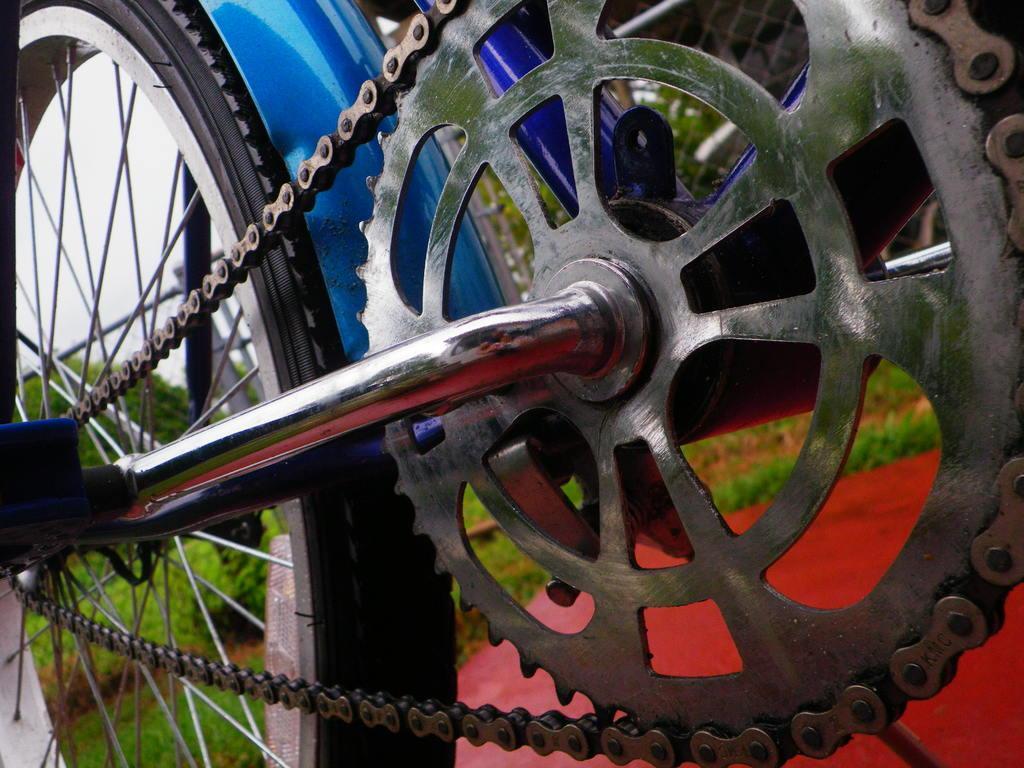Can you describe this image briefly? In the center of the image we can see cycle. In the background we can see trees, plants, grass and sky. 